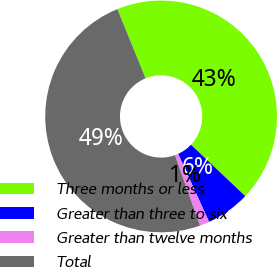Convert chart to OTSL. <chart><loc_0><loc_0><loc_500><loc_500><pie_chart><fcel>Three months or less<fcel>Greater than three to six<fcel>Greater than twelve months<fcel>Total<nl><fcel>43.23%<fcel>6.14%<fcel>1.35%<fcel>49.29%<nl></chart> 